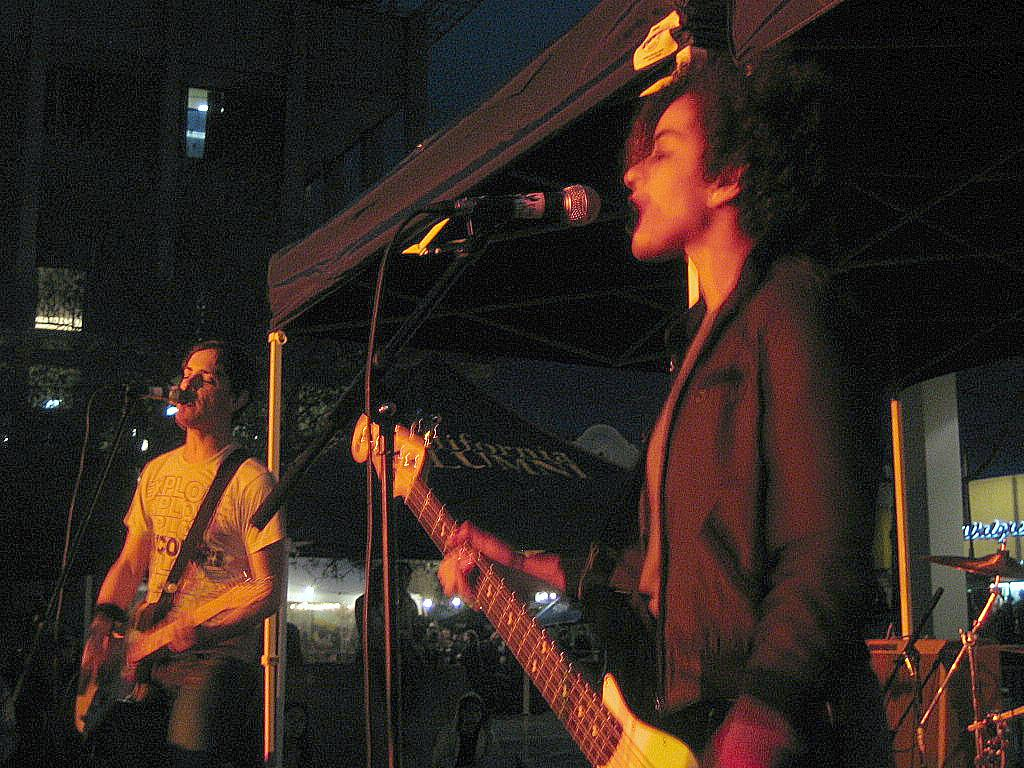What are the two persons in the image doing? The two persons are playing guitar and singing. What objects are in front of the persons? There are microphones in front of the persons. What can be seen in the background of the image? There are buildings in the background. What is the tendency of the squirrel in the image? There is no squirrel present in the image, so it is not possible to determine its tendency. 